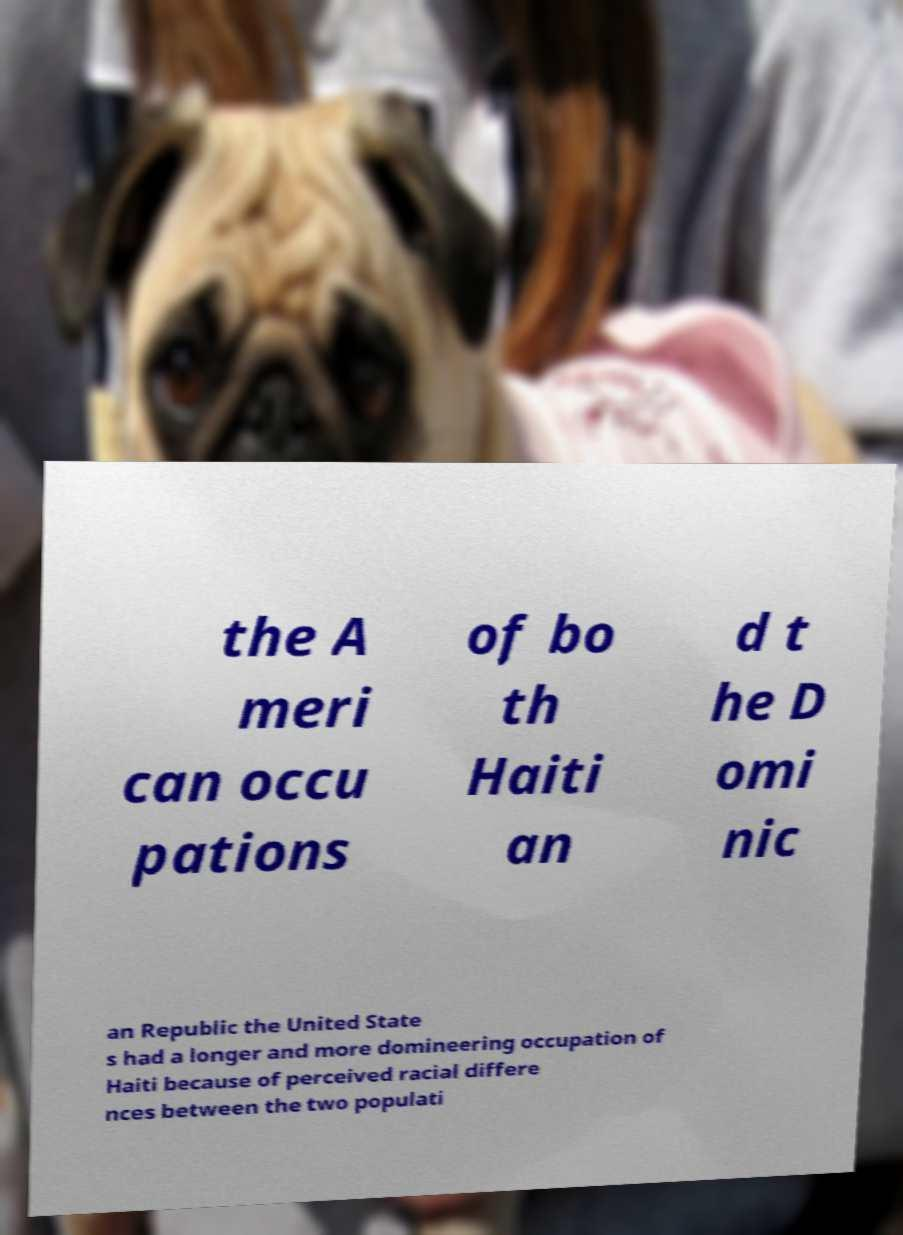There's text embedded in this image that I need extracted. Can you transcribe it verbatim? the A meri can occu pations of bo th Haiti an d t he D omi nic an Republic the United State s had a longer and more domineering occupation of Haiti because of perceived racial differe nces between the two populati 